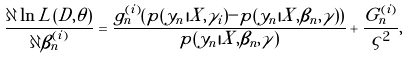<formula> <loc_0><loc_0><loc_500><loc_500>\frac { \partial \ln L ( D , \theta ) } { \partial \beta _ { n } ^ { ( i ) } } = \frac { g _ { n } ^ { ( i ) } ( p ( y _ { n } | X , \gamma _ { i } ) - p ( y _ { n } | X , \beta _ { n } , \gamma ) ) } { p ( y _ { n } | X , \beta _ { n } , \gamma ) } + \frac { G _ { n } ^ { ( i ) } } { \varsigma ^ { 2 } } ,</formula> 